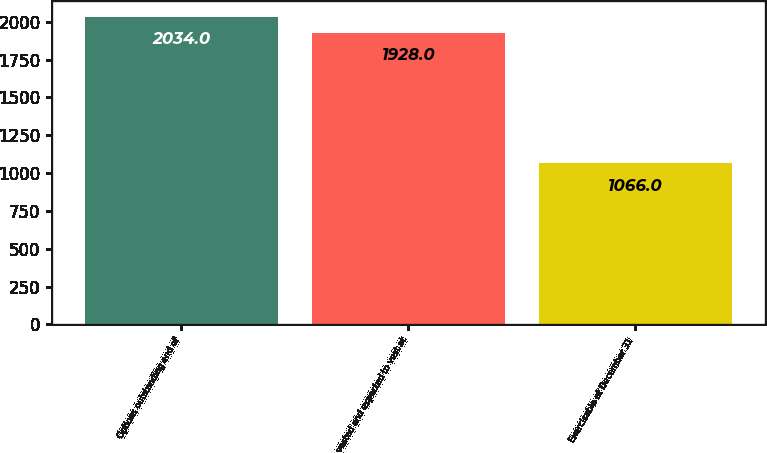Convert chart to OTSL. <chart><loc_0><loc_0><loc_500><loc_500><bar_chart><fcel>Options outstanding end of<fcel>vested and expected to vest at<fcel>Exercisable at December 31<nl><fcel>2034<fcel>1928<fcel>1066<nl></chart> 